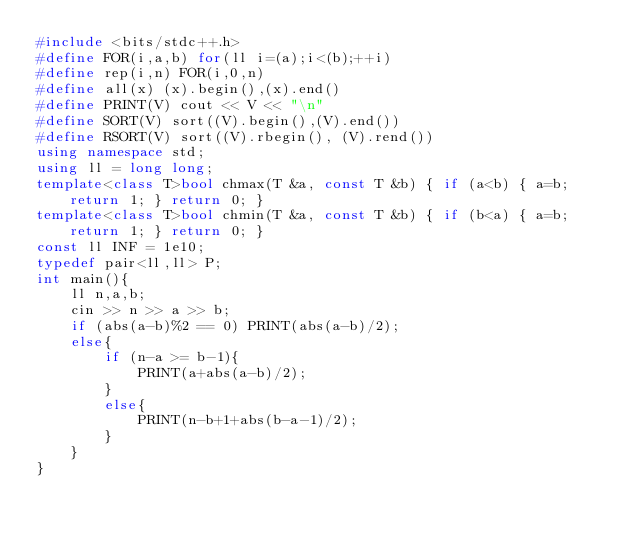<code> <loc_0><loc_0><loc_500><loc_500><_C++_>#include <bits/stdc++.h>
#define FOR(i,a,b) for(ll i=(a);i<(b);++i)
#define rep(i,n) FOR(i,0,n)
#define all(x) (x).begin(),(x).end()
#define PRINT(V) cout << V << "\n"
#define SORT(V) sort((V).begin(),(V).end())
#define RSORT(V) sort((V).rbegin(), (V).rend())
using namespace std;
using ll = long long;
template<class T>bool chmax(T &a, const T &b) { if (a<b) { a=b; return 1; } return 0; }
template<class T>bool chmin(T &a, const T &b) { if (b<a) { a=b; return 1; } return 0; }
const ll INF = 1e10;
typedef pair<ll,ll> P;
int main(){
    ll n,a,b;
    cin >> n >> a >> b;
    if (abs(a-b)%2 == 0) PRINT(abs(a-b)/2);
    else{
        if (n-a >= b-1){
            PRINT(a+abs(a-b)/2);
        }
        else{
            PRINT(n-b+1+abs(b-a-1)/2);
        }
    }
}
</code> 